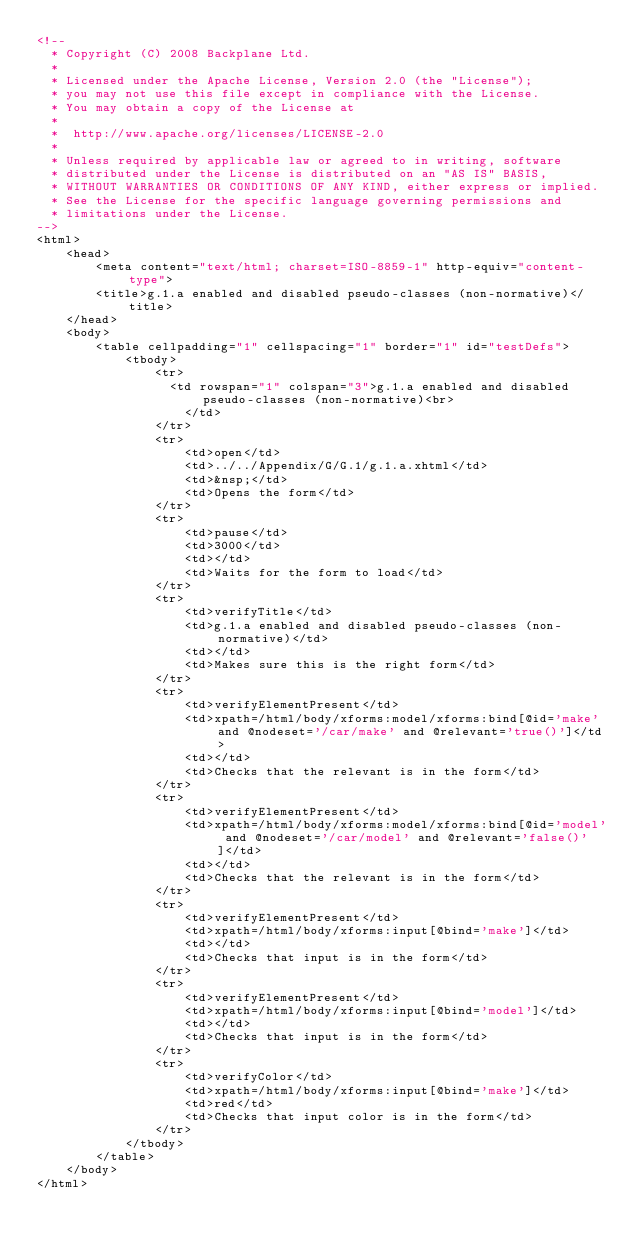Convert code to text. <code><loc_0><loc_0><loc_500><loc_500><_HTML_><!--
  * Copyright (C) 2008 Backplane Ltd.
  *
  * Licensed under the Apache License, Version 2.0 (the "License");
  * you may not use this file except in compliance with the License.
  * You may obtain a copy of the License at
  *
  *  http://www.apache.org/licenses/LICENSE-2.0
  *
  * Unless required by applicable law or agreed to in writing, software
  * distributed under the License is distributed on an "AS IS" BASIS,
  * WITHOUT WARRANTIES OR CONDITIONS OF ANY KIND, either express or implied.
  * See the License for the specific language governing permissions and
  * limitations under the License.
-->
<html>
	<head>
		<meta content="text/html; charset=ISO-8859-1" http-equiv="content-type">
		<title>g.1.a enabled and disabled pseudo-classes (non-normative)</title>
	</head>
	<body>
		<table cellpadding="1" cellspacing="1" border="1" id="testDefs">
			<tbody>
				<tr>
				  <td rowspan="1" colspan="3">g.1.a enabled and disabled pseudo-classes (non-normative)<br>
					</td>
				</tr>
				<tr>
					<td>open</td>
					<td>../../Appendix/G/G.1/g.1.a.xhtml</td>
					<td>&nsp;</td>
					<td>Opens the form</td>
				</tr>
				<tr>
					<td>pause</td>
					<td>3000</td>
					<td></td>
					<td>Waits for the form to load</td>
				</tr>
				<tr>
					<td>verifyTitle</td>
					<td>g.1.a enabled and disabled pseudo-classes (non-normative)</td>
					<td></td>
					<td>Makes sure this is the right form</td>
				</tr>
				<tr>
					<td>verifyElementPresent</td>
					<td>xpath=/html/body/xforms:model/xforms:bind[@id='make' and @nodeset='/car/make' and @relevant='true()']</td>
					<td></td>
					<td>Checks that the relevant is in the form</td>
				</tr>
				<tr>
					<td>verifyElementPresent</td>
					<td>xpath=/html/body/xforms:model/xforms:bind[@id='model' and @nodeset='/car/model' and @relevant='false()']</td>
					<td></td>
					<td>Checks that the relevant is in the form</td>
				</tr>
				<tr>
					<td>verifyElementPresent</td>
					<td>xpath=/html/body/xforms:input[@bind='make']</td>
					<td></td>
					<td>Checks that input is in the form</td>
				</tr>
				<tr>
					<td>verifyElementPresent</td>
					<td>xpath=/html/body/xforms:input[@bind='model']</td>
					<td></td>
					<td>Checks that input is in the form</td>
				</tr>
				<tr>
					<td>verifyColor</td>
					<td>xpath=/html/body/xforms:input[@bind='make']</td>
					<td>red</td>
					<td>Checks that input color is in the form</td>
				</tr>
			</tbody>
		</table>
	</body>
</html>
</code> 